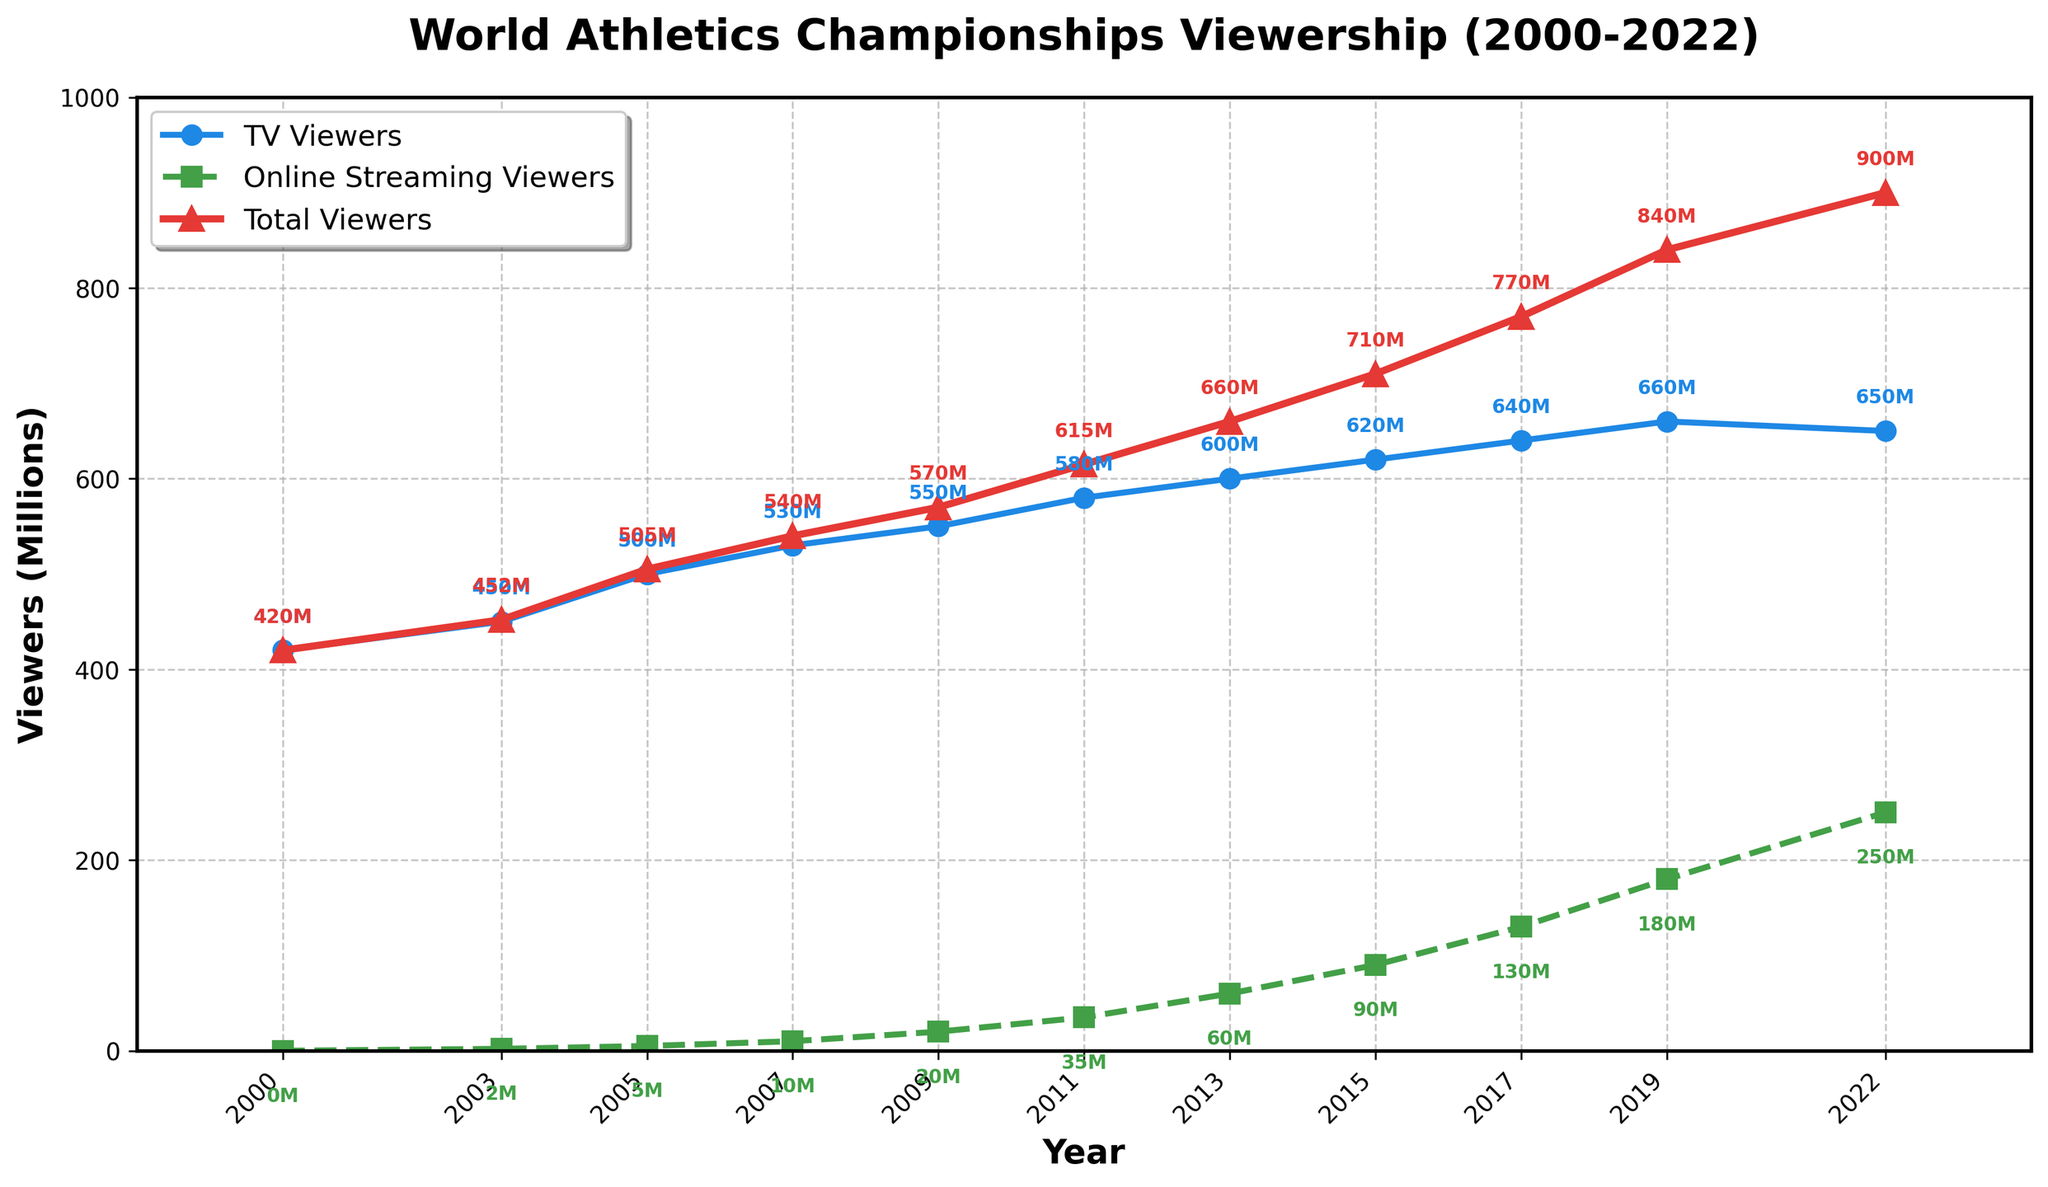How many total viewers were there in 2019? Based on the figure, navigate to the year 2019 on the x-axis and locate the corresponding value of the 'Total Viewers' series (represented by red markers). The annotation reads 840M.
Answer: 840M What was the trend in the number of TV viewers from 2000 to 2017? To identify the trend, observe the blue line associated with 'TV Viewers' from 2000 to 2017. The line shows a consistent upward trajectory, indicating an increasing trend in TV viewers over this period.
Answer: Increasing Which year had the highest number of online streaming viewers? Look for the highest point on the green dashed line representing 'Online Streaming Viewers'. The peak value is at the year 2022 with an annotation of 250M.
Answer: 2022 Compare the number of TV viewers and online streaming viewers in 2015. Locate the year 2015 on the x-axis and find the values for both 'TV Viewers' (blue line) and 'Online Streaming Viewers' (green dashed line). The 'TV Viewers' annotation shows 620M and the 'Online Streaming Viewers' annotation shows 90M.
Answer: 620M (TV Viewers), 90M (Online Streaming Viewers) What is the difference in the total viewership between 2013 and 2022? Find the annotated 'Total Viewers' values for 2013 and 2022. In 2013, it's 660M, and in 2022, it's 900M. Subtract the 2013 value from the 2022 value to find the difference (900M - 660M).
Answer: 240M Determine the average number of TV viewers over the period of 2000 to 2022. Add the TV Viewers values from each year: 420 + 450 + 500 + 530 + 550 + 580 + 600 + 620 + 640 + 660 + 650. The total is 6200M. Divide by the number of years (11) to find the average: 6200M / 11.
Answer: 563.64M In which years did the total viewership exceed 700M? Identify the 'Total Viewers' values with annotations above 700M. The relevant years are 2017 (770M), 2019 (840M), and 2022 (900M).
Answer: 2017, 2019, 2022 What is the cumulative increase in online streaming viewers from 2003 to 2022? Calculate the difference in 'Online Streaming Viewers' between 2022 (250M) and 2003 (2M). Subtract the 2003 value from the 2022 value (250M - 2M), giving a cumulative increase.
Answer: 248M 